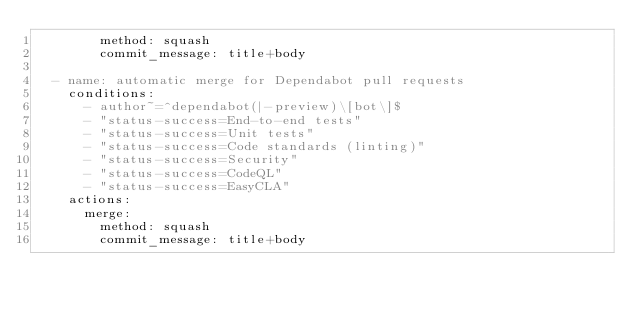<code> <loc_0><loc_0><loc_500><loc_500><_YAML_>        method: squash
        commit_message: title+body

  - name: automatic merge for Dependabot pull requests
    conditions:
      - author~=^dependabot(|-preview)\[bot\]$
      - "status-success=End-to-end tests"
      - "status-success=Unit tests"
      - "status-success=Code standards (linting)"
      - "status-success=Security"
      - "status-success=CodeQL"
      - "status-success=EasyCLA"
    actions:
      merge:
        method: squash
        commit_message: title+body
</code> 